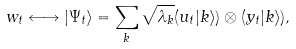Convert formula to latex. <formula><loc_0><loc_0><loc_500><loc_500>w _ { t } \longleftrightarrow | \Psi _ { t } \rangle = \sum _ { k } \sqrt { \lambda _ { k } } ( u _ { t } | k \rangle ) \otimes ( y _ { t } | k \rangle ) ,</formula> 